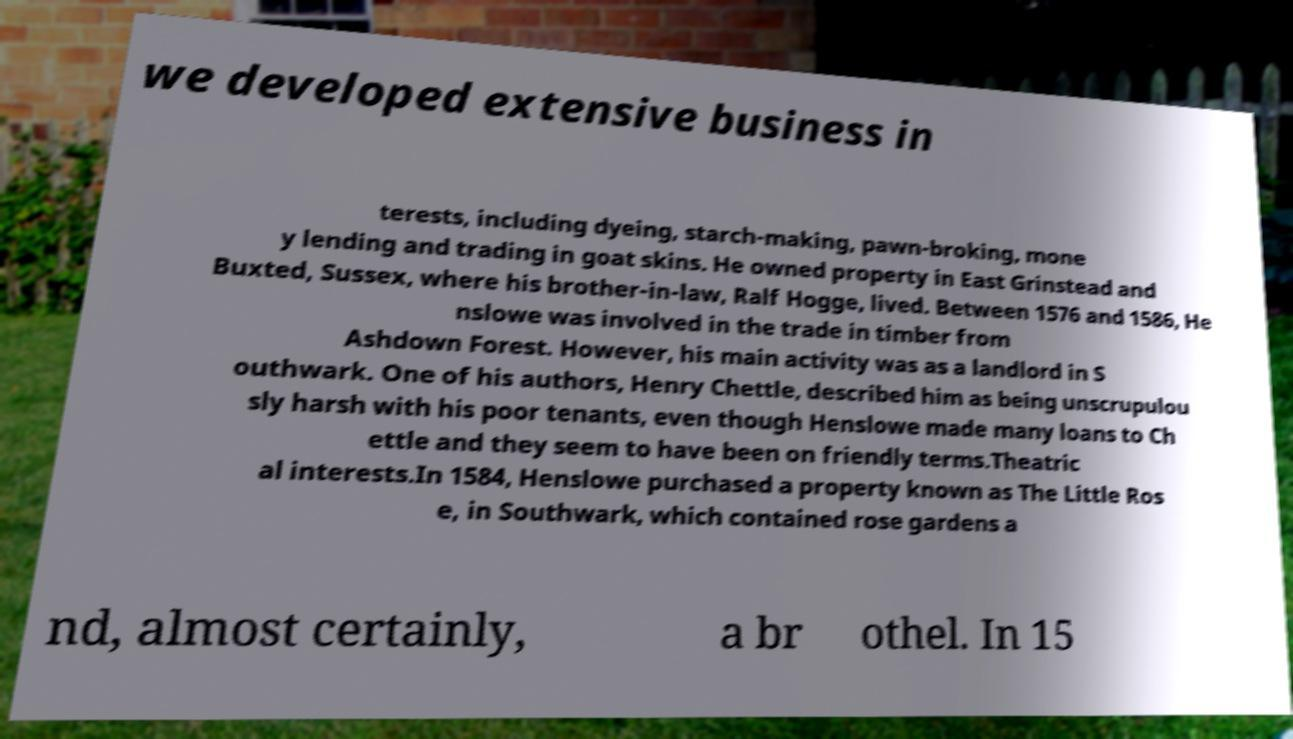What messages or text are displayed in this image? I need them in a readable, typed format. we developed extensive business in terests, including dyeing, starch-making, pawn-broking, mone y lending and trading in goat skins. He owned property in East Grinstead and Buxted, Sussex, where his brother-in-law, Ralf Hogge, lived. Between 1576 and 1586, He nslowe was involved in the trade in timber from Ashdown Forest. However, his main activity was as a landlord in S outhwark. One of his authors, Henry Chettle, described him as being unscrupulou sly harsh with his poor tenants, even though Henslowe made many loans to Ch ettle and they seem to have been on friendly terms.Theatric al interests.In 1584, Henslowe purchased a property known as The Little Ros e, in Southwark, which contained rose gardens a nd, almost certainly, a br othel. In 15 